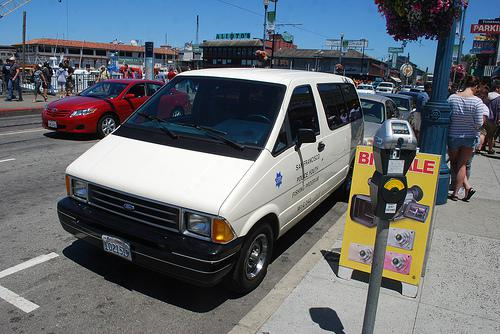Question: what is the metal device on the pole?
Choices:
A. A camera.
B. Parking meter.
C. A car counter.
D. A traffic light.
Answer with the letter. Answer: B Question: where is this shot?
Choices:
A. Street.
B. Inside a restaurant.
C. Sidewalk.
D. At a park.
Answer with the letter. Answer: C Question: when was this shot?
Choices:
A. Nighttime.
B. Dawn.
C. Dusk.
D. Daytime.
Answer with the letter. Answer: D Question: how many parking meters are shown?
Choices:
A. 1.
B. 2.
C. 3.
D. 4.
Answer with the letter. Answer: A Question: how many tires can be seen?
Choices:
A. 4.
B. 2.
C. 7.
D. 9.
Answer with the letter. Answer: B 